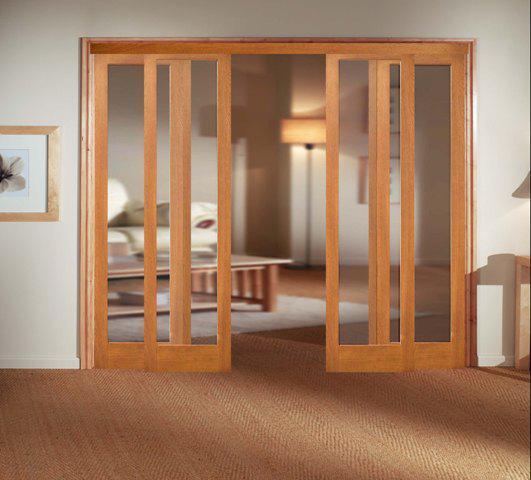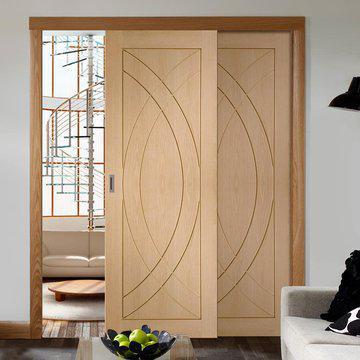The first image is the image on the left, the second image is the image on the right. Analyze the images presented: Is the assertion "One image shows wooden sliding doors with overlapping semi-circle designs on them." valid? Answer yes or no. Yes. The first image is the image on the left, the second image is the image on the right. Assess this claim about the two images: "There are two chairs in the image on the left.". Correct or not? Answer yes or no. No. 